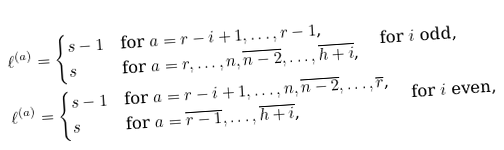<formula> <loc_0><loc_0><loc_500><loc_500>\ell ^ { ( a ) } & = \begin{cases} s - 1 & \text {for $a=r-i+1,\dots,r-1$,} \\ s & \text {for $a=r,\dots,n,\overline{n-2},\dots,\overline{h+i}$,} \end{cases} \quad \text {for $i$ odd,} \\ \ell ^ { ( a ) } & = \begin{cases} s - 1 & \text {for $a=r-i+1,\dots,n,\overline{n-2},\dots,\overline{r}$,} \\ s & \text {for $a=\overline{r-1},\dots,\overline{h+i}$,} \end{cases} \quad \text {for $i$ even,}</formula> 